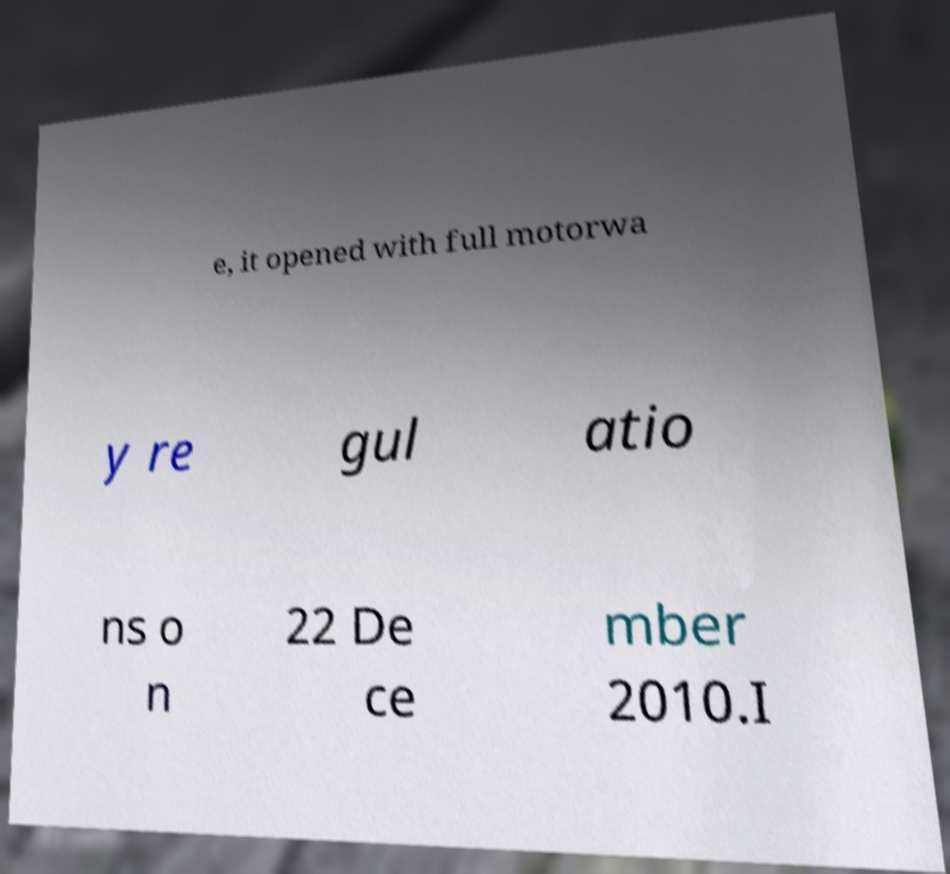There's text embedded in this image that I need extracted. Can you transcribe it verbatim? e, it opened with full motorwa y re gul atio ns o n 22 De ce mber 2010.I 